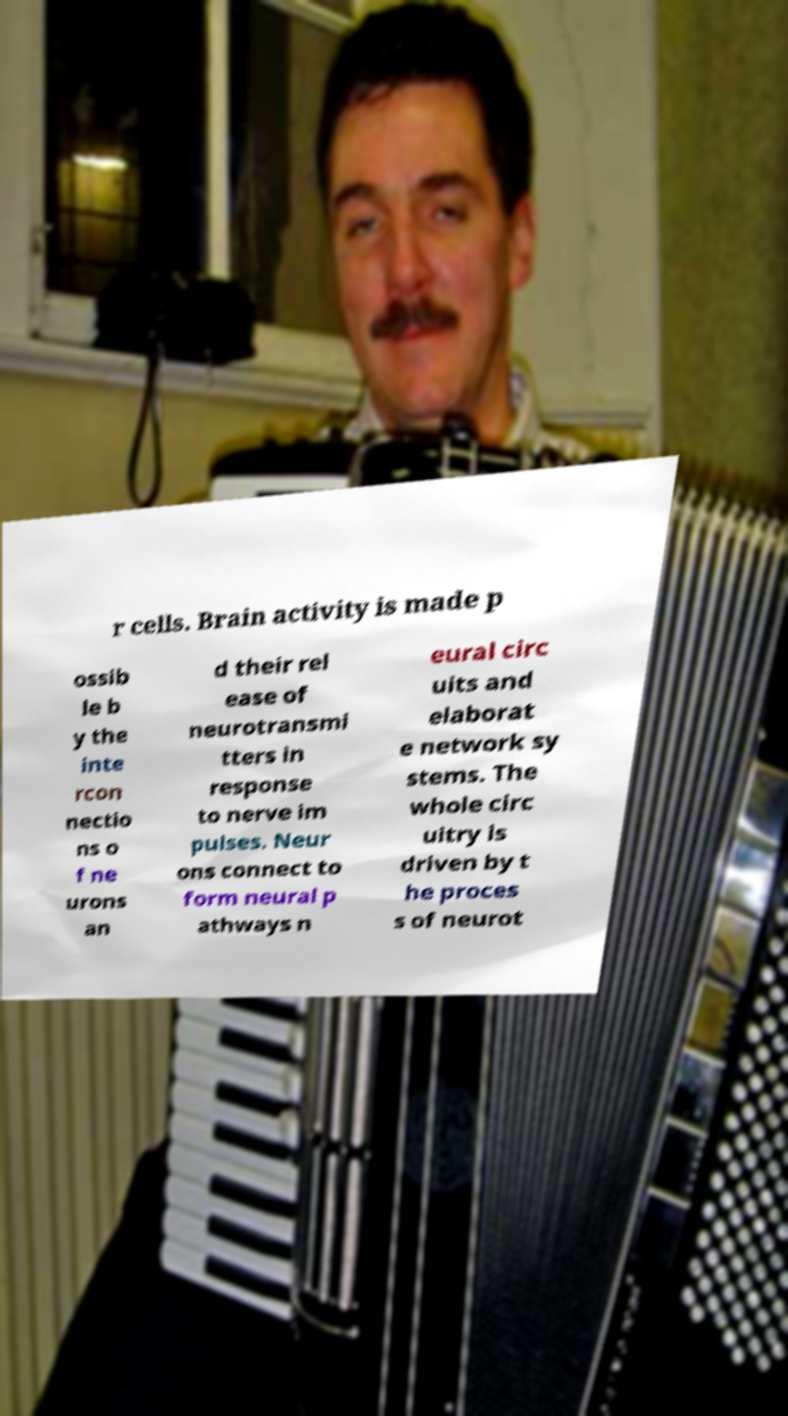Could you extract and type out the text from this image? r cells. Brain activity is made p ossib le b y the inte rcon nectio ns o f ne urons an d their rel ease of neurotransmi tters in response to nerve im pulses. Neur ons connect to form neural p athways n eural circ uits and elaborat e network sy stems. The whole circ uitry is driven by t he proces s of neurot 